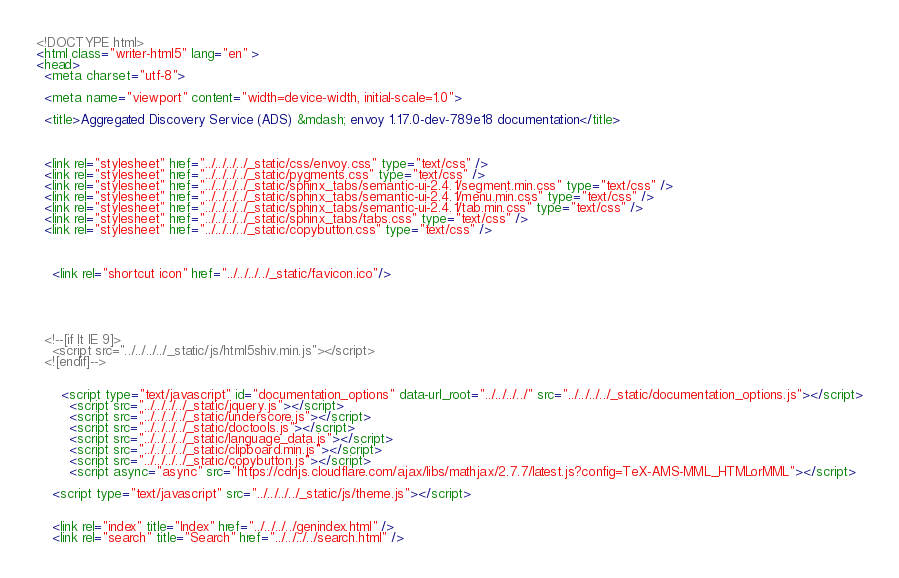<code> <loc_0><loc_0><loc_500><loc_500><_HTML_>

<!DOCTYPE html>
<html class="writer-html5" lang="en" >
<head>
  <meta charset="utf-8">
  
  <meta name="viewport" content="width=device-width, initial-scale=1.0">
  
  <title>Aggregated Discovery Service (ADS) &mdash; envoy 1.17.0-dev-789e18 documentation</title>
  

  
  <link rel="stylesheet" href="../../../../_static/css/envoy.css" type="text/css" />
  <link rel="stylesheet" href="../../../../_static/pygments.css" type="text/css" />
  <link rel="stylesheet" href="../../../../_static/sphinx_tabs/semantic-ui-2.4.1/segment.min.css" type="text/css" />
  <link rel="stylesheet" href="../../../../_static/sphinx_tabs/semantic-ui-2.4.1/menu.min.css" type="text/css" />
  <link rel="stylesheet" href="../../../../_static/sphinx_tabs/semantic-ui-2.4.1/tab.min.css" type="text/css" />
  <link rel="stylesheet" href="../../../../_static/sphinx_tabs/tabs.css" type="text/css" />
  <link rel="stylesheet" href="../../../../_static/copybutton.css" type="text/css" />

  
  
    <link rel="shortcut icon" href="../../../../_static/favicon.ico"/>
  
  
  

  
  <!--[if lt IE 9]>
    <script src="../../../../_static/js/html5shiv.min.js"></script>
  <![endif]-->
  
    
      <script type="text/javascript" id="documentation_options" data-url_root="../../../../" src="../../../../_static/documentation_options.js"></script>
        <script src="../../../../_static/jquery.js"></script>
        <script src="../../../../_static/underscore.js"></script>
        <script src="../../../../_static/doctools.js"></script>
        <script src="../../../../_static/language_data.js"></script>
        <script src="../../../../_static/clipboard.min.js"></script>
        <script src="../../../../_static/copybutton.js"></script>
        <script async="async" src="https://cdnjs.cloudflare.com/ajax/libs/mathjax/2.7.7/latest.js?config=TeX-AMS-MML_HTMLorMML"></script>
    
    <script type="text/javascript" src="../../../../_static/js/theme.js"></script>

    
    <link rel="index" title="Index" href="../../../../genindex.html" />
    <link rel="search" title="Search" href="../../../../search.html" /></code> 